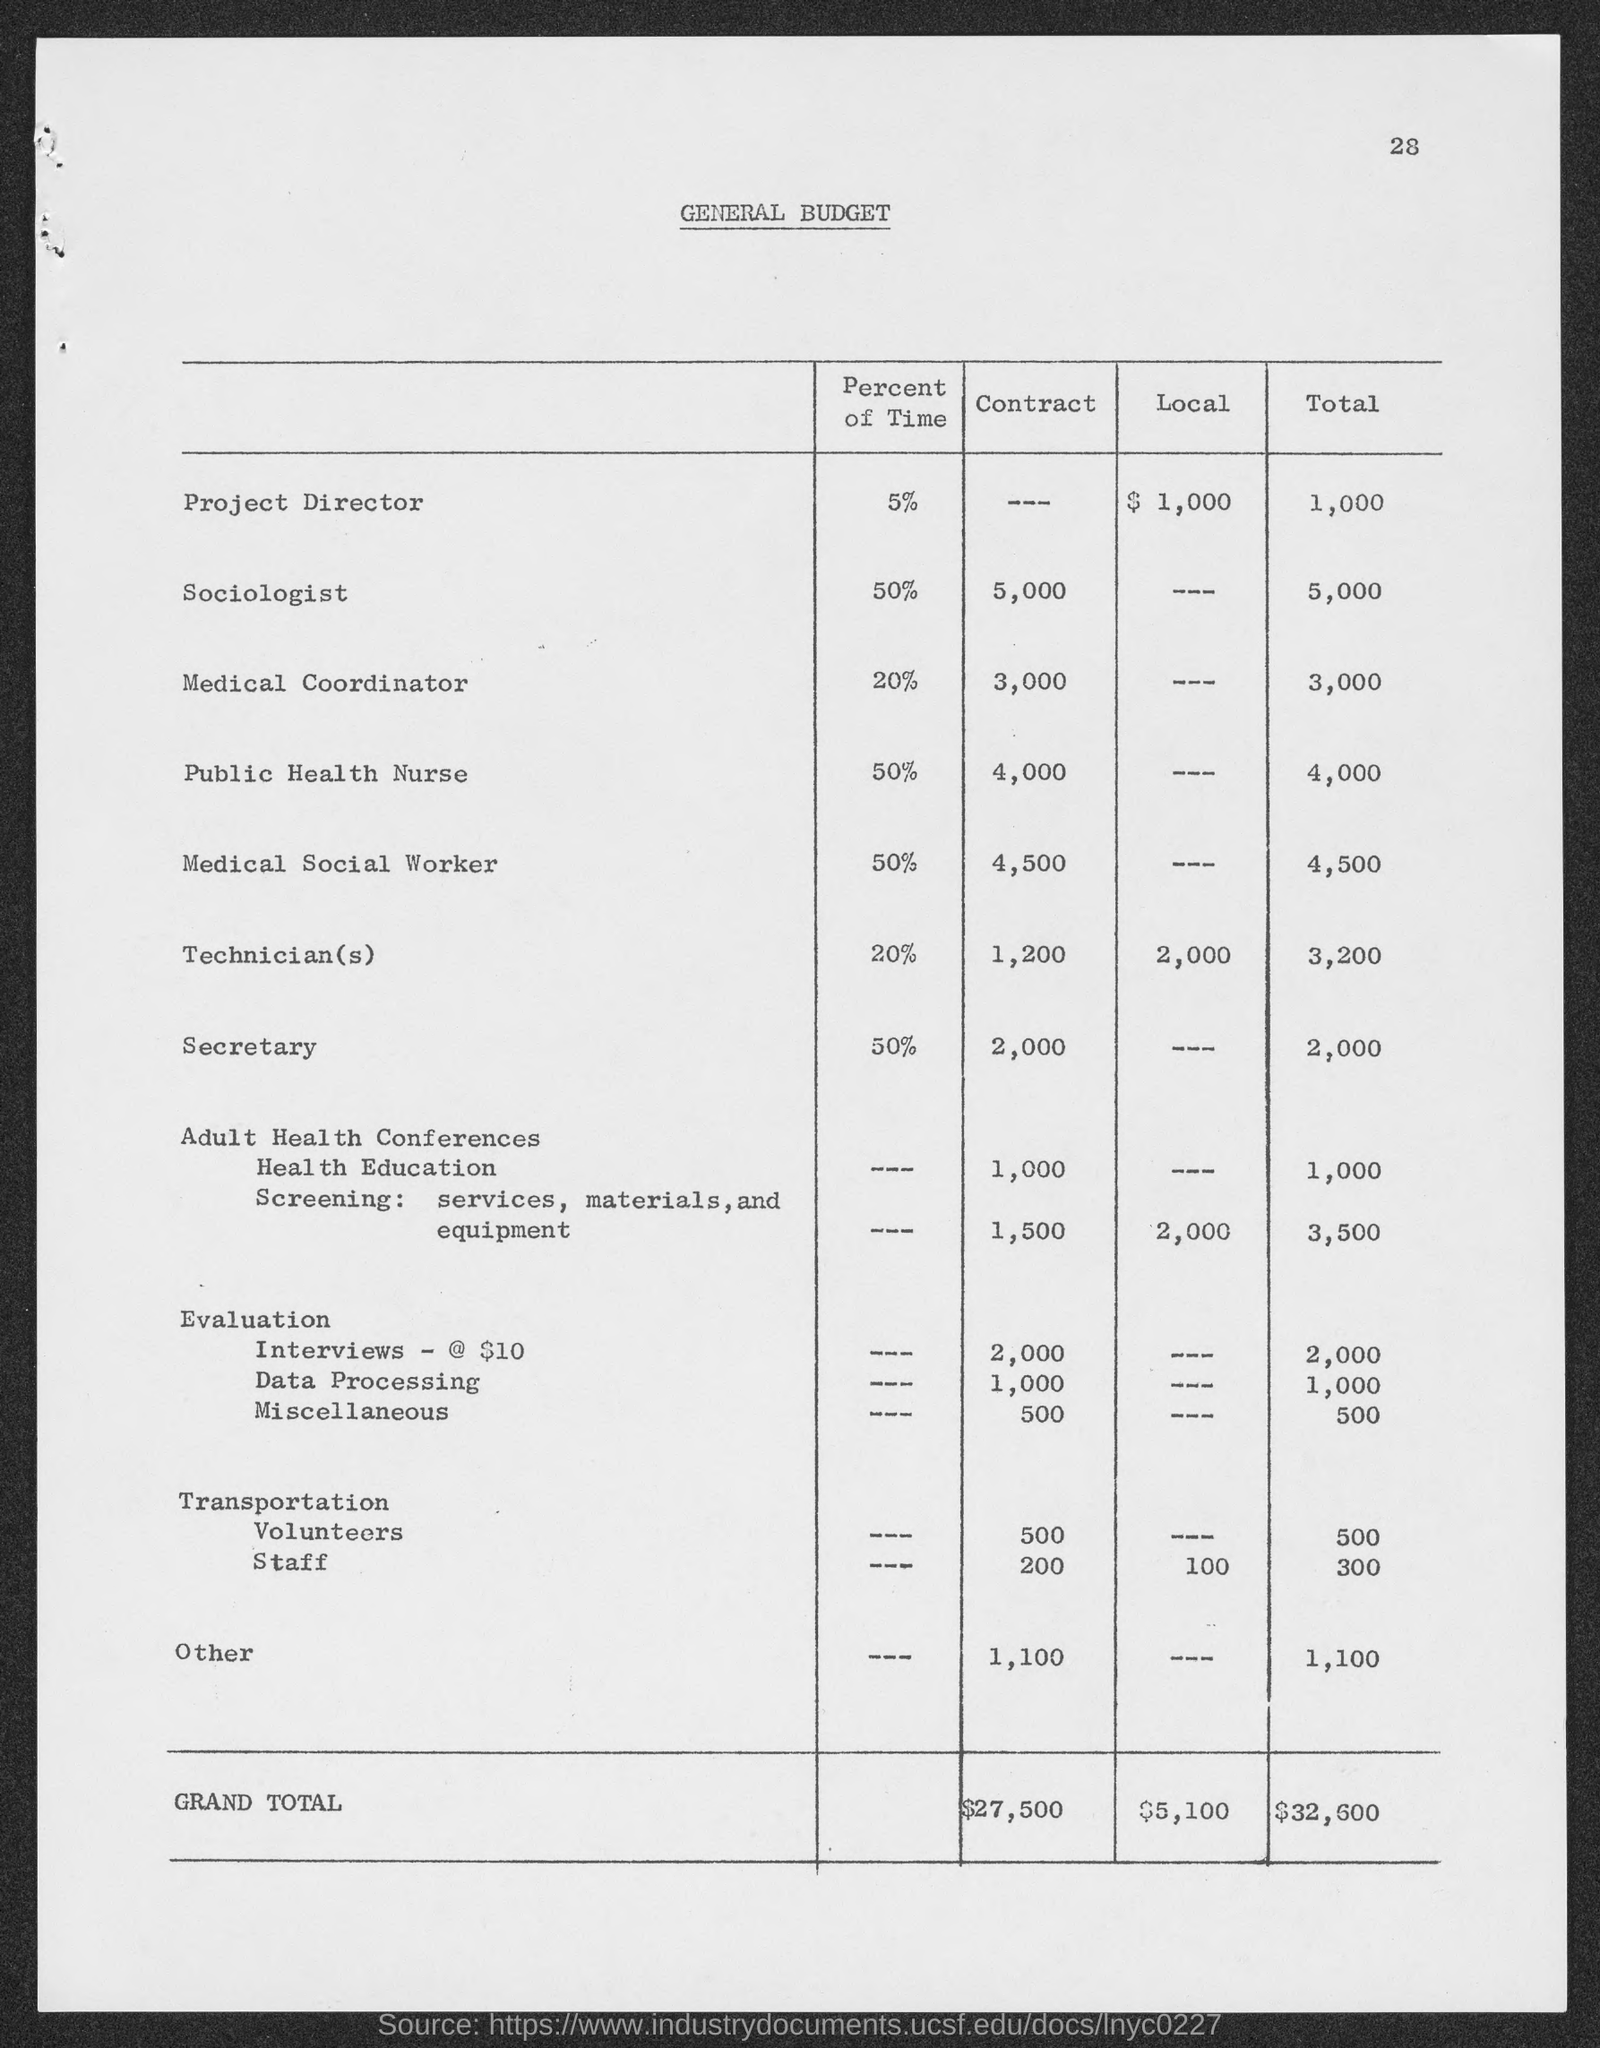Could you explain the breakdown of the Evaluation budget? Sure, the Evaluation budget is broken down into three parts: Interviews - $10 with a total of $2,000, Data Processing at $1,000, and Miscellaneous expenses amounting to $500, making the total Evaluation budget $3,500. 